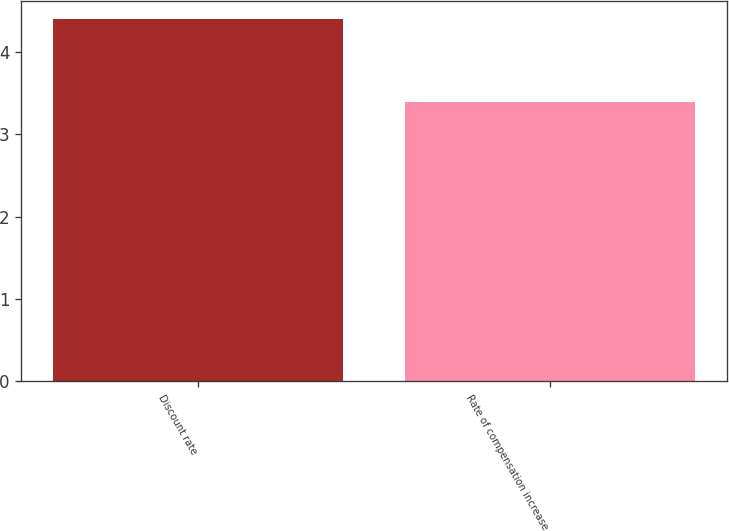Convert chart. <chart><loc_0><loc_0><loc_500><loc_500><bar_chart><fcel>Discount rate<fcel>Rate of compensation increase<nl><fcel>4.4<fcel>3.4<nl></chart> 